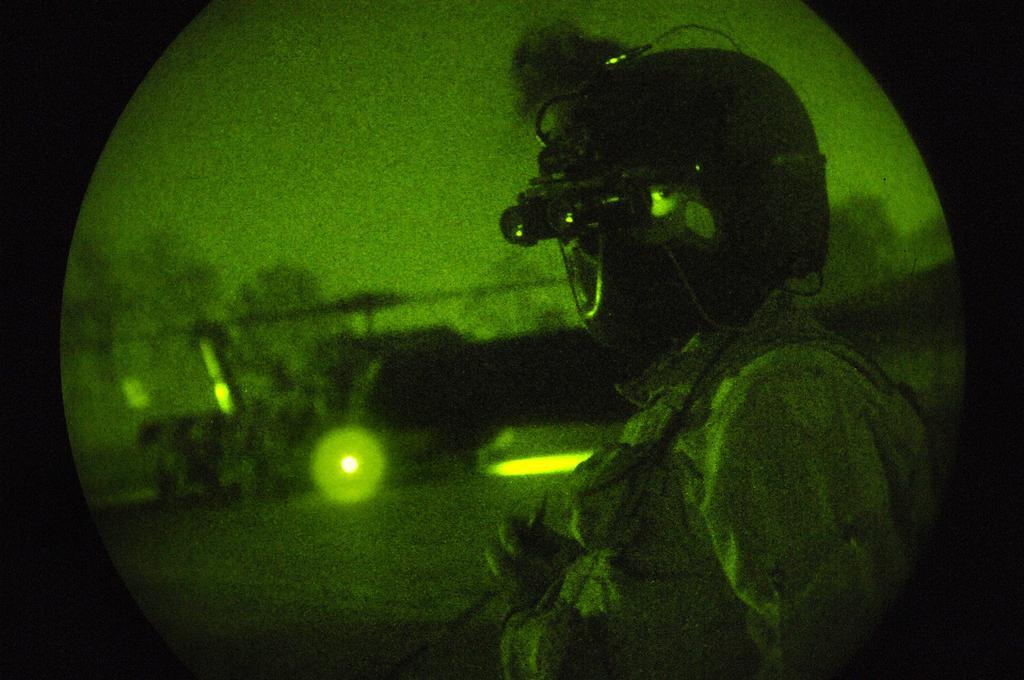Can you describe this image briefly? In this image we can see a person wearing helmet and the background is green and blurry. 